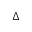<formula> <loc_0><loc_0><loc_500><loc_500>\Delta</formula> 